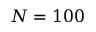<formula> <loc_0><loc_0><loc_500><loc_500>N = 1 0 0</formula> 